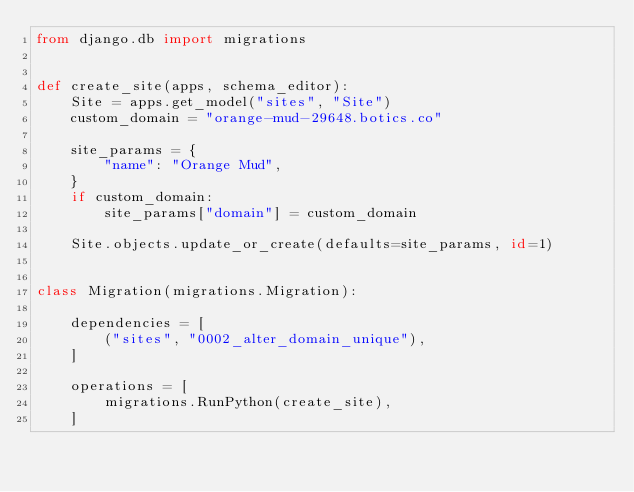<code> <loc_0><loc_0><loc_500><loc_500><_Python_>from django.db import migrations


def create_site(apps, schema_editor):
    Site = apps.get_model("sites", "Site")
    custom_domain = "orange-mud-29648.botics.co"

    site_params = {
        "name": "Orange Mud",
    }
    if custom_domain:
        site_params["domain"] = custom_domain

    Site.objects.update_or_create(defaults=site_params, id=1)


class Migration(migrations.Migration):

    dependencies = [
        ("sites", "0002_alter_domain_unique"),
    ]

    operations = [
        migrations.RunPython(create_site),
    ]
</code> 